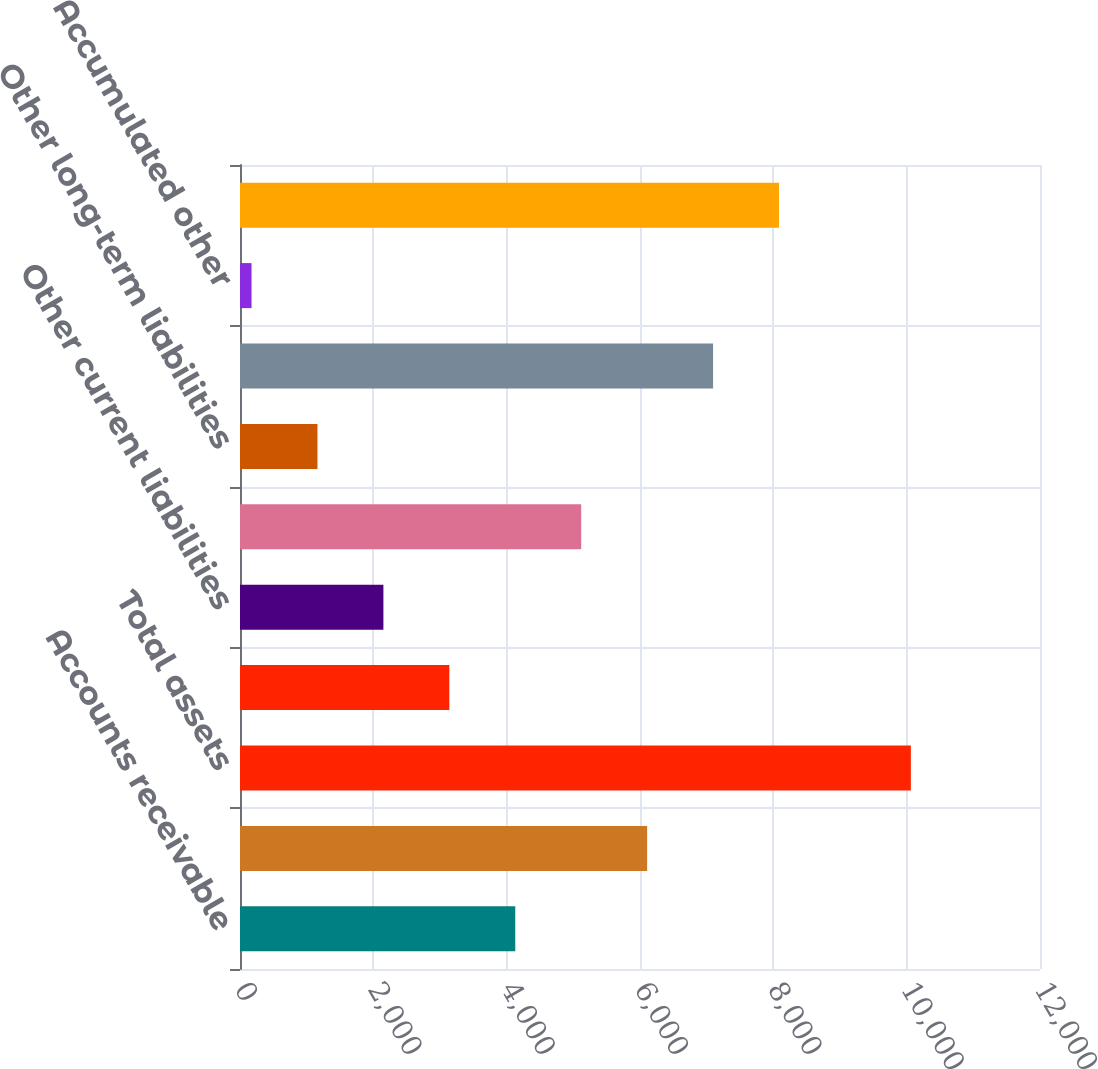Convert chart to OTSL. <chart><loc_0><loc_0><loc_500><loc_500><bar_chart><fcel>Accounts receivable<fcel>Current assets<fcel>Total assets<fcel>Accounts payable<fcel>Other current liabilities<fcel>Current liabilities<fcel>Other long-term liabilities<fcel>Additional paid-in capital<fcel>Accumulated other<fcel>Retained earnings (deficit)<nl><fcel>4129<fcel>6107<fcel>10063<fcel>3140<fcel>2151<fcel>5118<fcel>1162<fcel>7096<fcel>173<fcel>8085<nl></chart> 